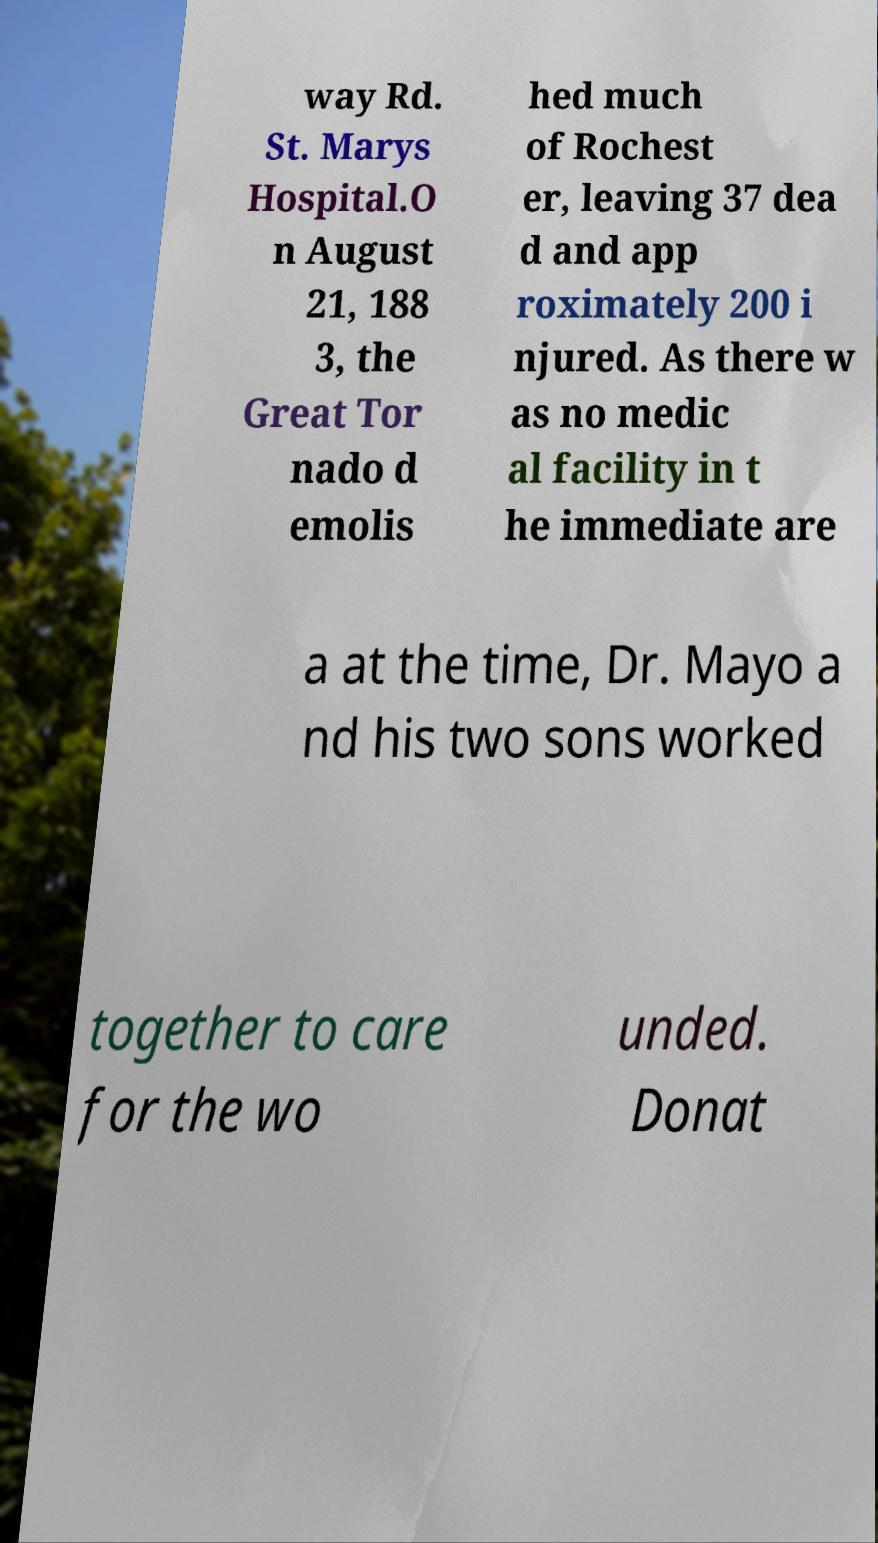Can you read and provide the text displayed in the image?This photo seems to have some interesting text. Can you extract and type it out for me? way Rd. St. Marys Hospital.O n August 21, 188 3, the Great Tor nado d emolis hed much of Rochest er, leaving 37 dea d and app roximately 200 i njured. As there w as no medic al facility in t he immediate are a at the time, Dr. Mayo a nd his two sons worked together to care for the wo unded. Donat 